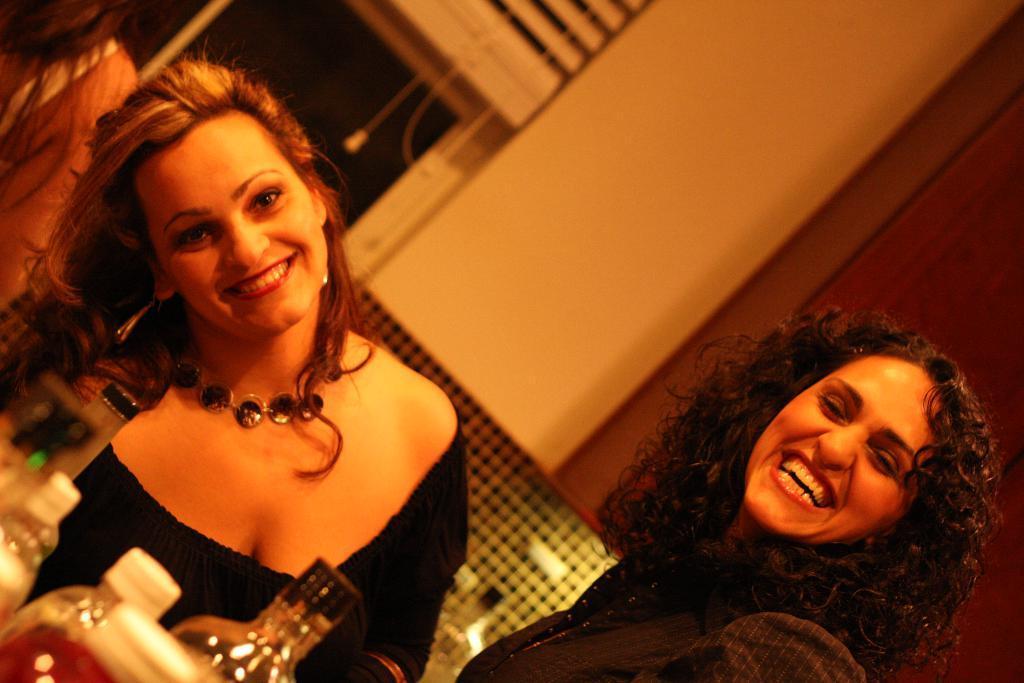Describe this image in one or two sentences. In the image we can see two women wearing clothes and they are smiling, a woman is wearing neck chain and earrings. Here we can see the bottles, wall, window and window blinds. It looks like there is another person, on the top left wearing clothes. 